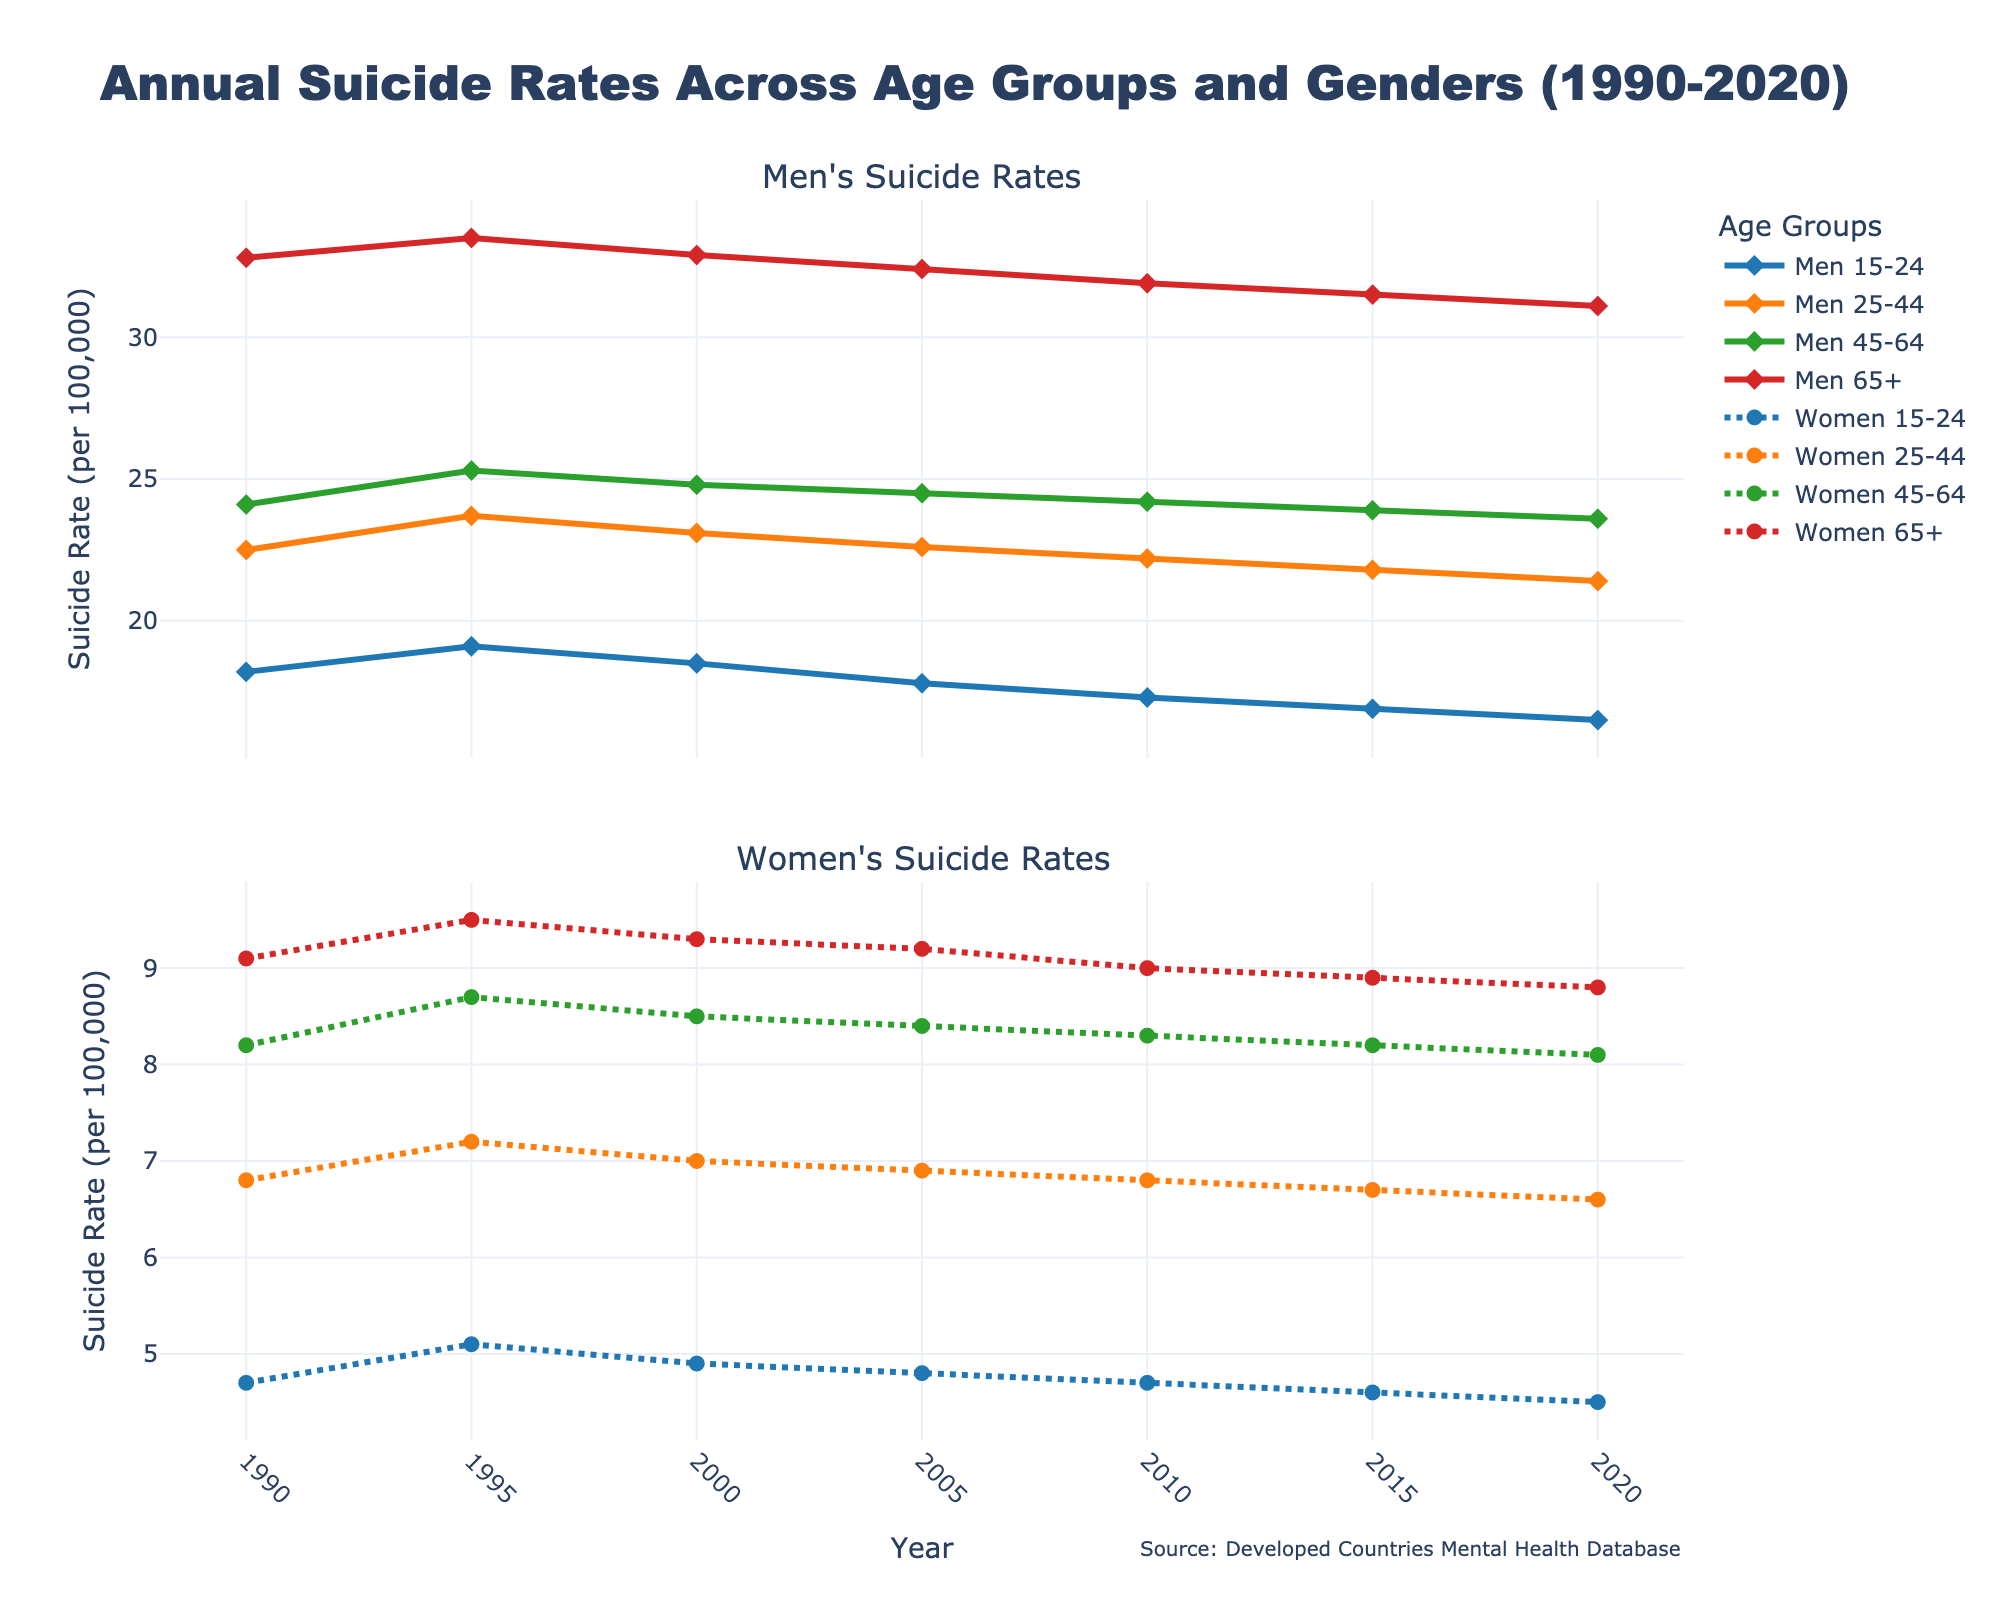What's the trend in suicide rates for Men aged 65+ from 1990 to 2020? The line representing Men aged 65+ shows a downward trend from 32.8 in 1990 to 31.1 in 2020. This indicates a gradual decrease over the 30-year period.
Answer: Downward trend Between Men aged 25-44 and Women aged 25-44, who had higher suicide rates in 2010? Looking at the two lines for 2010, the rate for Men aged 25-44 (22.2) is higher than that for Women aged 25-44 (6.8).
Answer: Men aged 25-44 How much did the suicide rate for Women aged 15-24 change from 1990 to 2020? The rate for Women aged 15-24 was 4.7 in 1990 and decreased to 4.5 by 2020. The change is calculated as 4.7 - 4.5 = 0.2.
Answer: Decreased by 0.2 Which group had the highest suicide rate in 1995? In 1995, the highest line on the graph corresponds to Men aged 65+ at a rate of 33.5.
Answer: Men aged 65+ Did the average suicide rate for all groups increase or decrease from 1990 to 2020? First, find the average rate for each year and then compare: 
1990: (18.2 + 22.5 + 24.1 + 32.8 + 4.7 + 6.8 + 8.2 + 9.1) / 8 = 15.3
2020: (16.5 + 21.4 + 23.6 + 31.1 + 4.5 + 6.6 + 8.1 + 8.8) / 8 = 15.07
Since 15.3 > 15.07, the average decreased.
Answer: Decreased Which group showed the least change in suicide rates between 1990 and 2020? Calculate the change for each group:
Men 15-24: 18.2 - 16.5 = 1.7
Men 25-44: 22.5 - 21.4 = 1.1
Men 45-64: 24.1 - 23.6 = 0.5
Men 65+: 32.8 - 31.1 = 1.7
Women 15-24: 4.7 - 4.5 = 0.2
Women 25-44: 6.8 - 6.6 = 0.2
Women 45-64: 8.2 - 8.1 = 0.1
Women 65+: 9.1 - 8.8 = 0.3
The least change is in Women aged 45-64 with 0.1.
Answer: Women 45-64 Compare the suicide rates of Men aged 45-64 and Men aged 65+ in 2020. In 2020, Men aged 45-64 have a rate of 23.6 and Men aged 65+ have a rate of 31.1. The rate for Men aged 65+ is higher.
Answer: Men aged 65+ What is the visual difference between the lines representing Men and Women aged 25-44? The line for Men aged 25-44 is solid with diamond markers, while the line for Women aged 25-44 is dotted with circle markers.
Answer: Solid vs. dotted line Which group had a consistent declining trend across the entire period from 1990 to 2020? Men aged 45-64 show a consistent downward trend from 24.1 in 1990 to 23.6 in 2020.
Answer: Men aged 45-64 